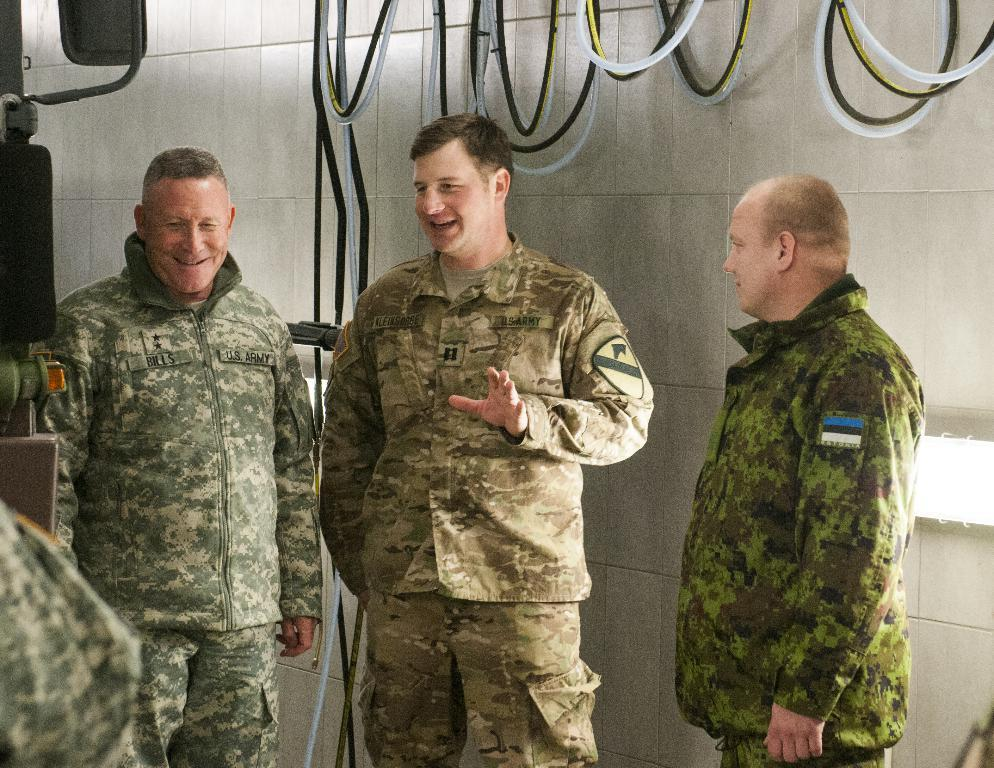Who is present in the image? There are people in the image. What are the people wearing? The people are wearing uniforms. What can be seen in the background of the image? There are pipes, a machine, and a wall visible in the background. What type of illumination is present in the image? There are lights visible in the image. How many folds are there in the uniforms of the people in the image? There is no information about the number of folds in the uniforms of the people in the image. Are there any cobwebs visible in the image? There is no mention of cobwebs in the provided facts, so it cannot be determined if any are present in the image. 